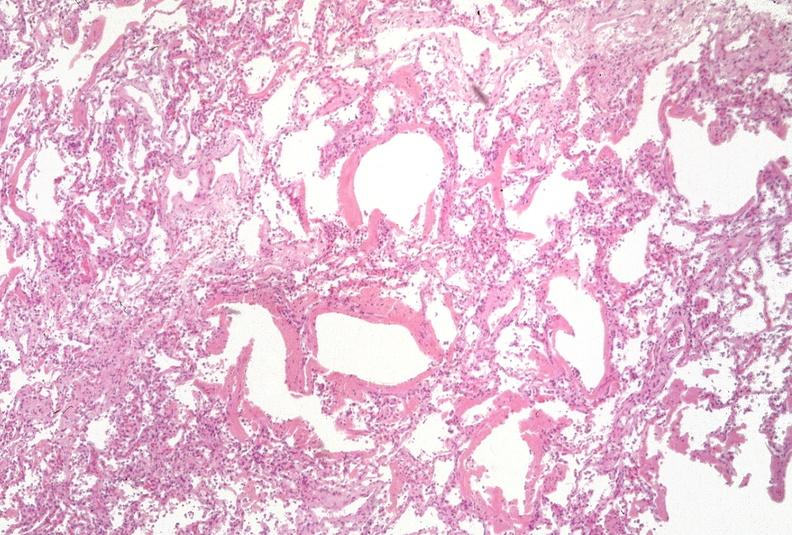does this image show lung?
Answer the question using a single word or phrase. Yes 